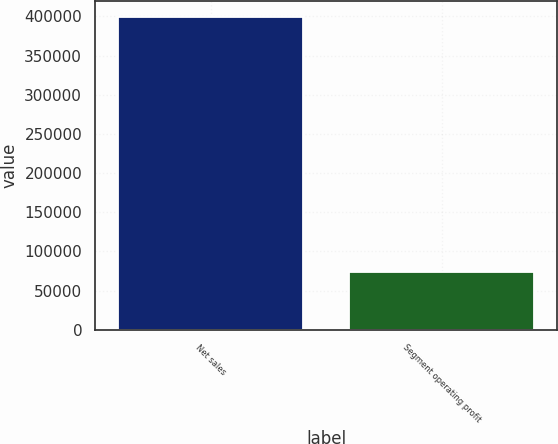Convert chart to OTSL. <chart><loc_0><loc_0><loc_500><loc_500><bar_chart><fcel>Net sales<fcel>Segment operating profit<nl><fcel>399276<fcel>74402<nl></chart> 